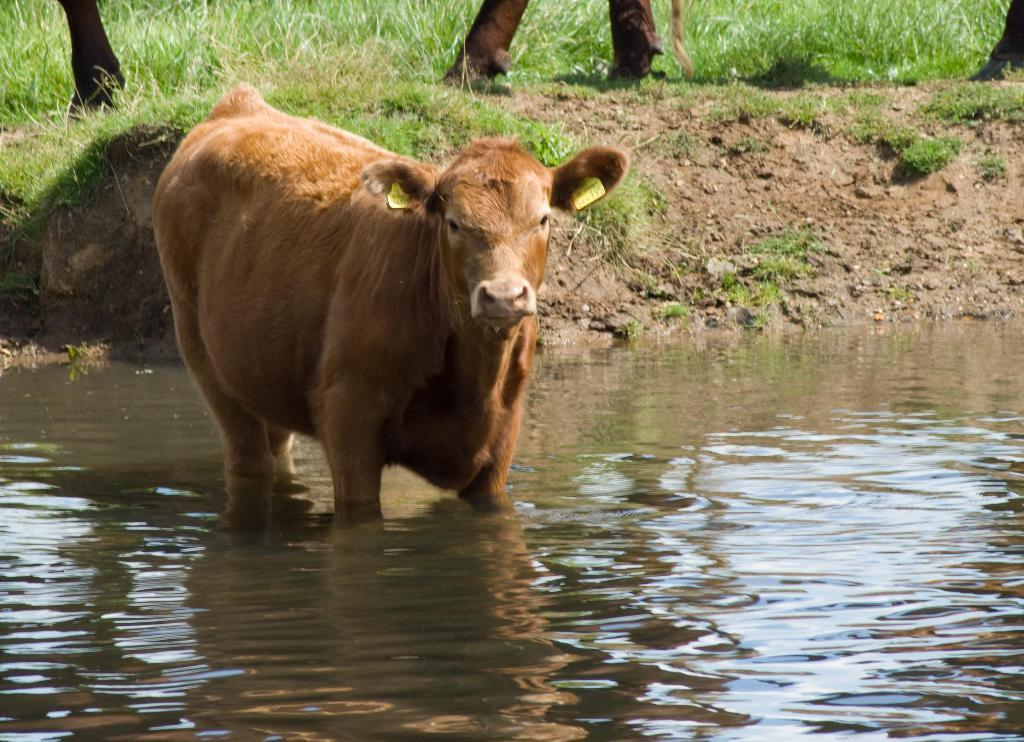What animal is present in the image? There is a cow in the image. Where is the cow located in the image? The cow is in the water. What type of vegetation can be seen in the image? There is grass visible in the image. Where is the grass located in relation to the cow? The grass is on the surface behind the cow. What type of sugar is being used to treat the cow's pain in the image? There is no sugar or indication of pain present in the image; it features a cow in the water with grass behind it. 